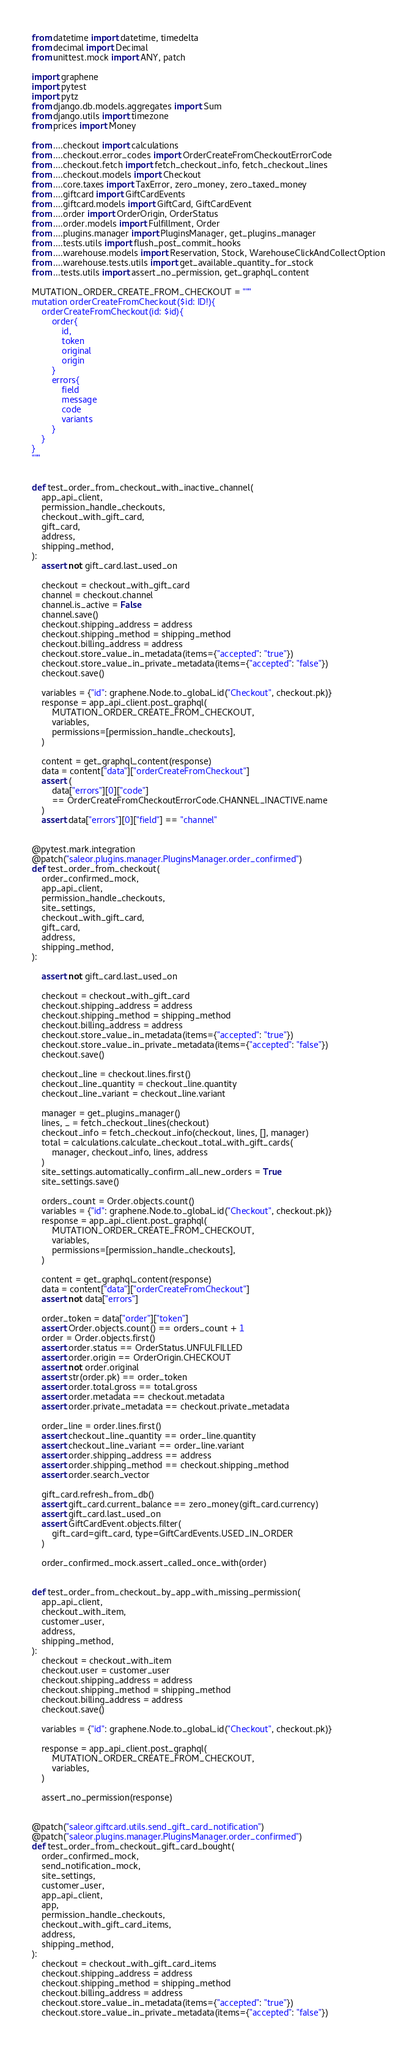<code> <loc_0><loc_0><loc_500><loc_500><_Python_>from datetime import datetime, timedelta
from decimal import Decimal
from unittest.mock import ANY, patch

import graphene
import pytest
import pytz
from django.db.models.aggregates import Sum
from django.utils import timezone
from prices import Money

from ....checkout import calculations
from ....checkout.error_codes import OrderCreateFromCheckoutErrorCode
from ....checkout.fetch import fetch_checkout_info, fetch_checkout_lines
from ....checkout.models import Checkout
from ....core.taxes import TaxError, zero_money, zero_taxed_money
from ....giftcard import GiftCardEvents
from ....giftcard.models import GiftCard, GiftCardEvent
from ....order import OrderOrigin, OrderStatus
from ....order.models import Fulfillment, Order
from ....plugins.manager import PluginsManager, get_plugins_manager
from ....tests.utils import flush_post_commit_hooks
from ....warehouse.models import Reservation, Stock, WarehouseClickAndCollectOption
from ....warehouse.tests.utils import get_available_quantity_for_stock
from ...tests.utils import assert_no_permission, get_graphql_content

MUTATION_ORDER_CREATE_FROM_CHECKOUT = """
mutation orderCreateFromCheckout($id: ID!){
    orderCreateFromCheckout(id: $id){
        order{
            id,
            token
            original
            origin
        }
        errors{
            field
            message
            code
            variants
        }
    }
}
"""


def test_order_from_checkout_with_inactive_channel(
    app_api_client,
    permission_handle_checkouts,
    checkout_with_gift_card,
    gift_card,
    address,
    shipping_method,
):
    assert not gift_card.last_used_on

    checkout = checkout_with_gift_card
    channel = checkout.channel
    channel.is_active = False
    channel.save()
    checkout.shipping_address = address
    checkout.shipping_method = shipping_method
    checkout.billing_address = address
    checkout.store_value_in_metadata(items={"accepted": "true"})
    checkout.store_value_in_private_metadata(items={"accepted": "false"})
    checkout.save()

    variables = {"id": graphene.Node.to_global_id("Checkout", checkout.pk)}
    response = app_api_client.post_graphql(
        MUTATION_ORDER_CREATE_FROM_CHECKOUT,
        variables,
        permissions=[permission_handle_checkouts],
    )

    content = get_graphql_content(response)
    data = content["data"]["orderCreateFromCheckout"]
    assert (
        data["errors"][0]["code"]
        == OrderCreateFromCheckoutErrorCode.CHANNEL_INACTIVE.name
    )
    assert data["errors"][0]["field"] == "channel"


@pytest.mark.integration
@patch("saleor.plugins.manager.PluginsManager.order_confirmed")
def test_order_from_checkout(
    order_confirmed_mock,
    app_api_client,
    permission_handle_checkouts,
    site_settings,
    checkout_with_gift_card,
    gift_card,
    address,
    shipping_method,
):

    assert not gift_card.last_used_on

    checkout = checkout_with_gift_card
    checkout.shipping_address = address
    checkout.shipping_method = shipping_method
    checkout.billing_address = address
    checkout.store_value_in_metadata(items={"accepted": "true"})
    checkout.store_value_in_private_metadata(items={"accepted": "false"})
    checkout.save()

    checkout_line = checkout.lines.first()
    checkout_line_quantity = checkout_line.quantity
    checkout_line_variant = checkout_line.variant

    manager = get_plugins_manager()
    lines, _ = fetch_checkout_lines(checkout)
    checkout_info = fetch_checkout_info(checkout, lines, [], manager)
    total = calculations.calculate_checkout_total_with_gift_cards(
        manager, checkout_info, lines, address
    )
    site_settings.automatically_confirm_all_new_orders = True
    site_settings.save()

    orders_count = Order.objects.count()
    variables = {"id": graphene.Node.to_global_id("Checkout", checkout.pk)}
    response = app_api_client.post_graphql(
        MUTATION_ORDER_CREATE_FROM_CHECKOUT,
        variables,
        permissions=[permission_handle_checkouts],
    )

    content = get_graphql_content(response)
    data = content["data"]["orderCreateFromCheckout"]
    assert not data["errors"]

    order_token = data["order"]["token"]
    assert Order.objects.count() == orders_count + 1
    order = Order.objects.first()
    assert order.status == OrderStatus.UNFULFILLED
    assert order.origin == OrderOrigin.CHECKOUT
    assert not order.original
    assert str(order.pk) == order_token
    assert order.total.gross == total.gross
    assert order.metadata == checkout.metadata
    assert order.private_metadata == checkout.private_metadata

    order_line = order.lines.first()
    assert checkout_line_quantity == order_line.quantity
    assert checkout_line_variant == order_line.variant
    assert order.shipping_address == address
    assert order.shipping_method == checkout.shipping_method
    assert order.search_vector

    gift_card.refresh_from_db()
    assert gift_card.current_balance == zero_money(gift_card.currency)
    assert gift_card.last_used_on
    assert GiftCardEvent.objects.filter(
        gift_card=gift_card, type=GiftCardEvents.USED_IN_ORDER
    )

    order_confirmed_mock.assert_called_once_with(order)


def test_order_from_checkout_by_app_with_missing_permission(
    app_api_client,
    checkout_with_item,
    customer_user,
    address,
    shipping_method,
):
    checkout = checkout_with_item
    checkout.user = customer_user
    checkout.shipping_address = address
    checkout.shipping_method = shipping_method
    checkout.billing_address = address
    checkout.save()

    variables = {"id": graphene.Node.to_global_id("Checkout", checkout.pk)}

    response = app_api_client.post_graphql(
        MUTATION_ORDER_CREATE_FROM_CHECKOUT,
        variables,
    )

    assert_no_permission(response)


@patch("saleor.giftcard.utils.send_gift_card_notification")
@patch("saleor.plugins.manager.PluginsManager.order_confirmed")
def test_order_from_checkout_gift_card_bought(
    order_confirmed_mock,
    send_notification_mock,
    site_settings,
    customer_user,
    app_api_client,
    app,
    permission_handle_checkouts,
    checkout_with_gift_card_items,
    address,
    shipping_method,
):
    checkout = checkout_with_gift_card_items
    checkout.shipping_address = address
    checkout.shipping_method = shipping_method
    checkout.billing_address = address
    checkout.store_value_in_metadata(items={"accepted": "true"})
    checkout.store_value_in_private_metadata(items={"accepted": "false"})</code> 